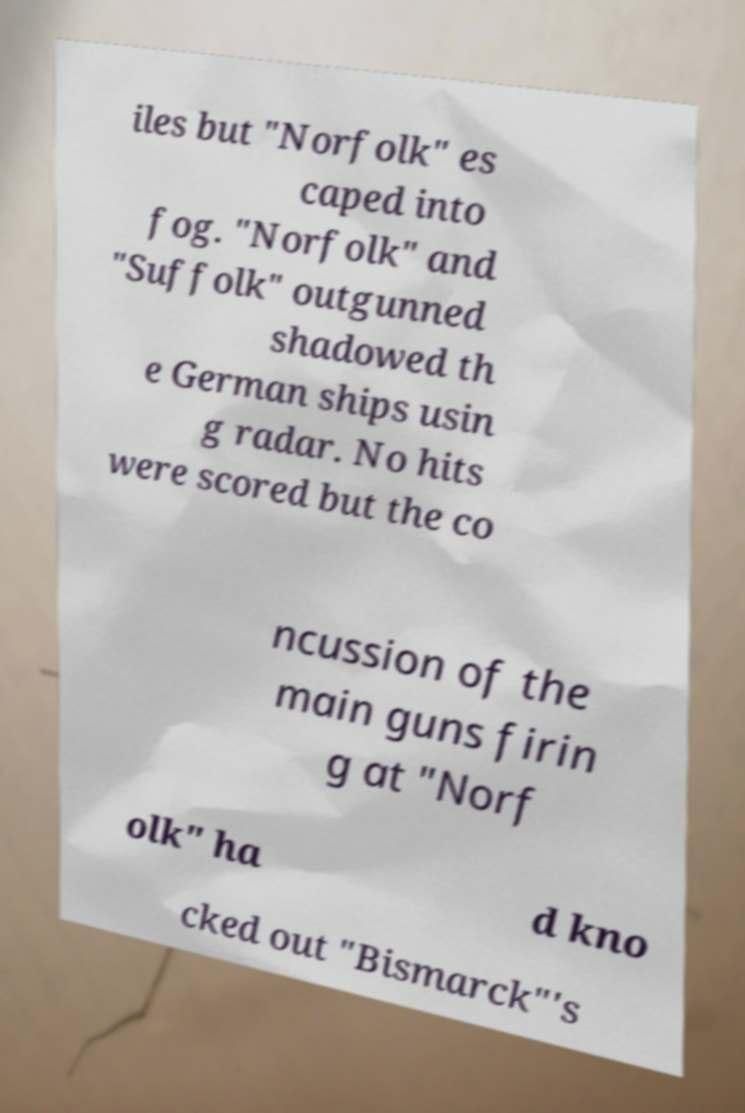Please identify and transcribe the text found in this image. iles but "Norfolk" es caped into fog. "Norfolk" and "Suffolk" outgunned shadowed th e German ships usin g radar. No hits were scored but the co ncussion of the main guns firin g at "Norf olk" ha d kno cked out "Bismarck"'s 